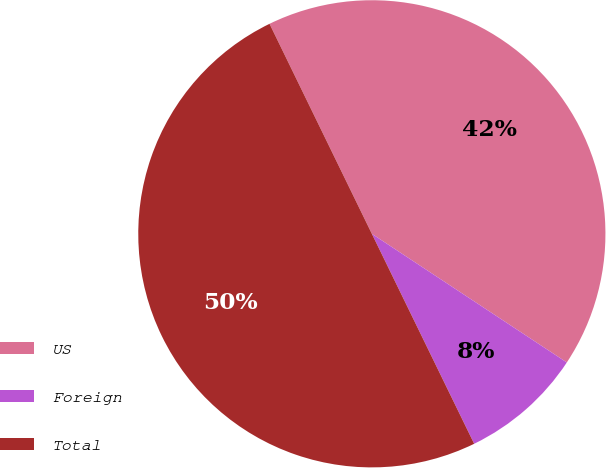<chart> <loc_0><loc_0><loc_500><loc_500><pie_chart><fcel>US<fcel>Foreign<fcel>Total<nl><fcel>41.5%<fcel>8.5%<fcel>50.0%<nl></chart> 